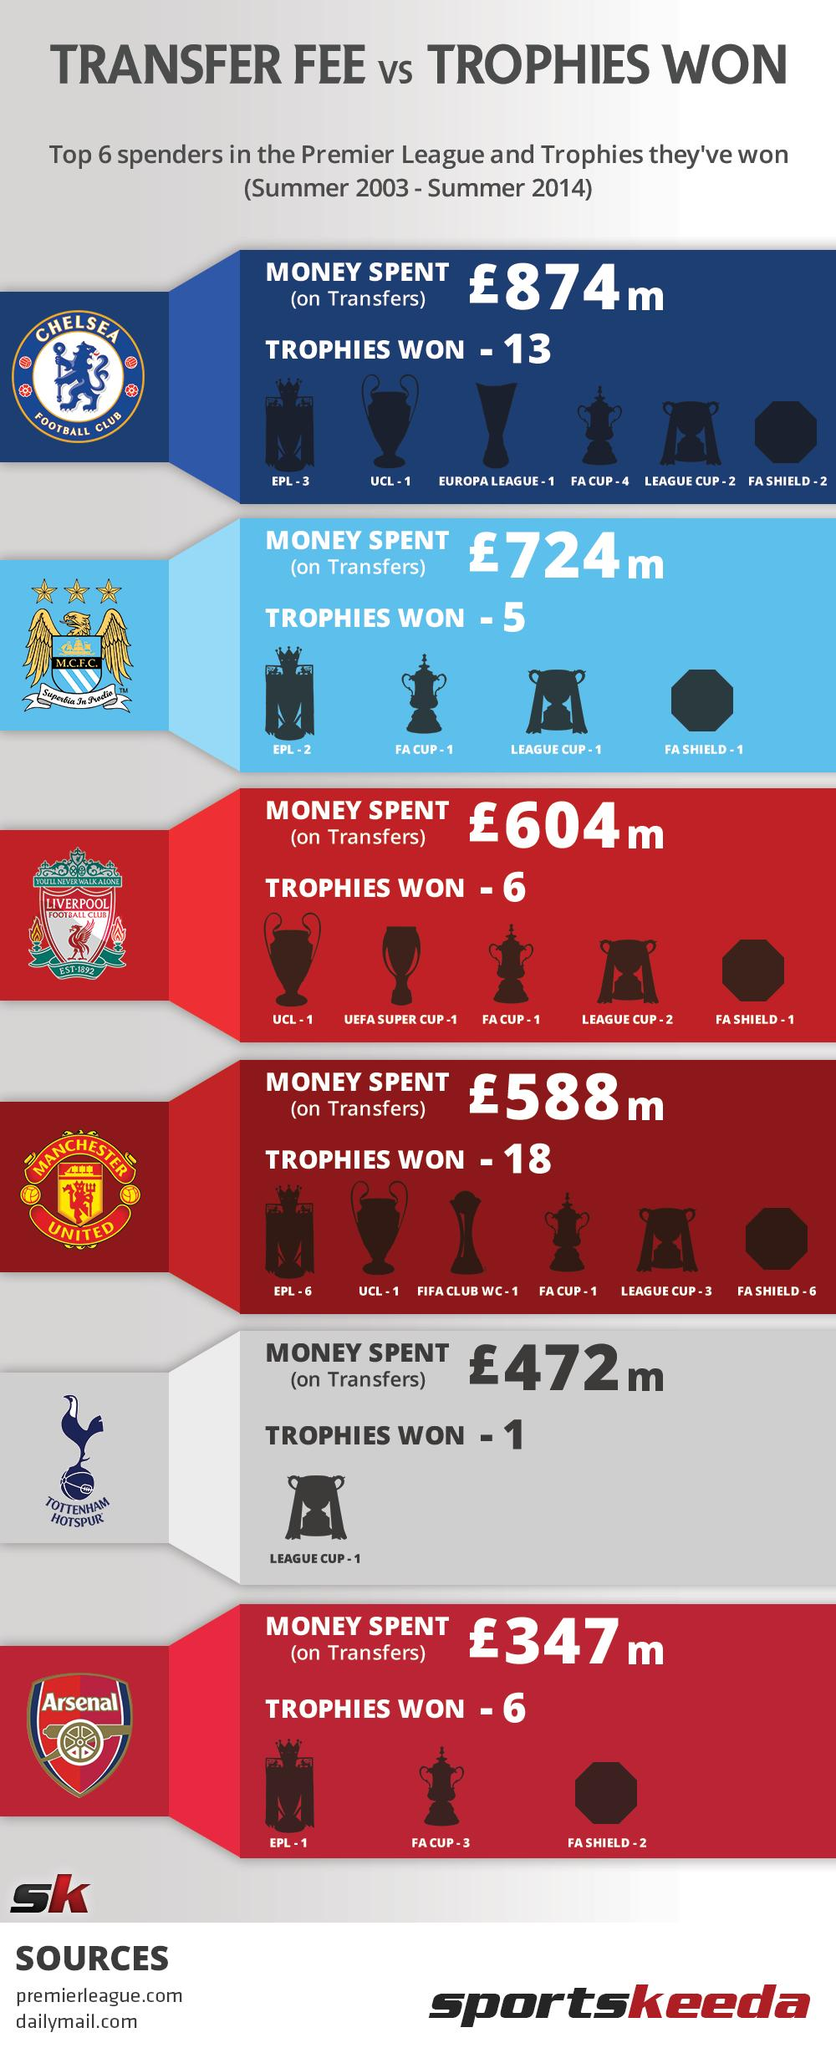Outline some significant characteristics in this image. Liverpool Football Club has won a total of three trophies in the League Cup and FA Cup. Tottenham Hotspur, listed in the infographic, have won the least number of trophies compared to the other teams. Chelsea Football Club has won a total of six trophies in the League Cup and FA Cup. Manchester United has won the most trophies out of the teams listed in the infographic. Manchester United have won more trophies than Chelsea Football Club by five. 